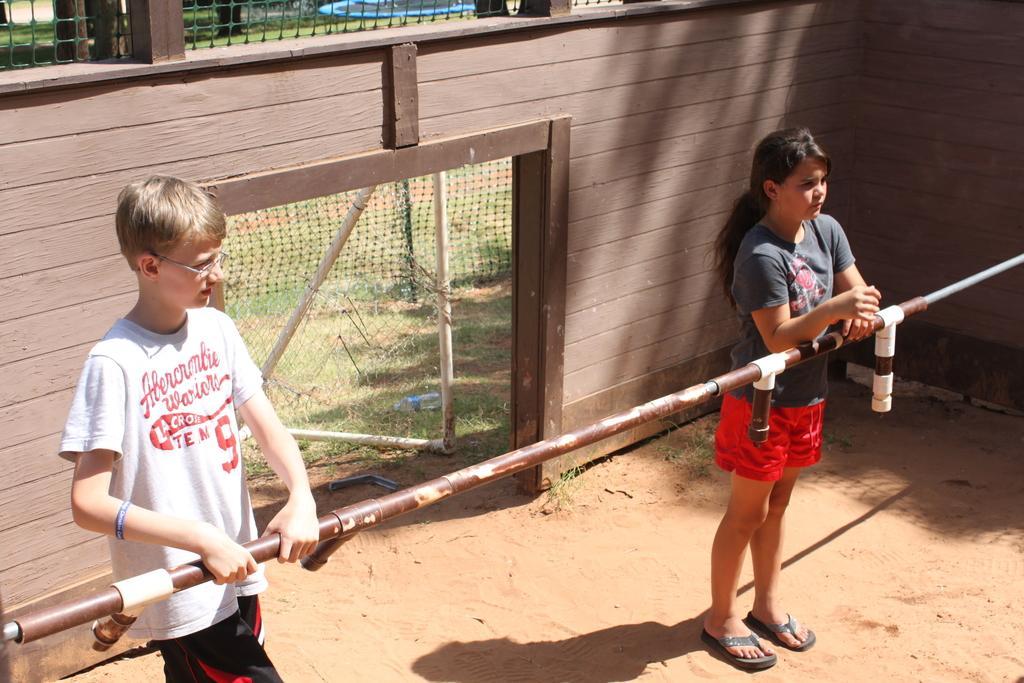In one or two sentences, can you explain what this image depicts? On the left side, there is a woman in white color t-shirt, standing and holding a rod. On the right side, there is a girl in red color short, standing on the ground. In front of her, there is a rod. In the background, there is a wall, there is a net and there is a bottle and grass on the ground. 